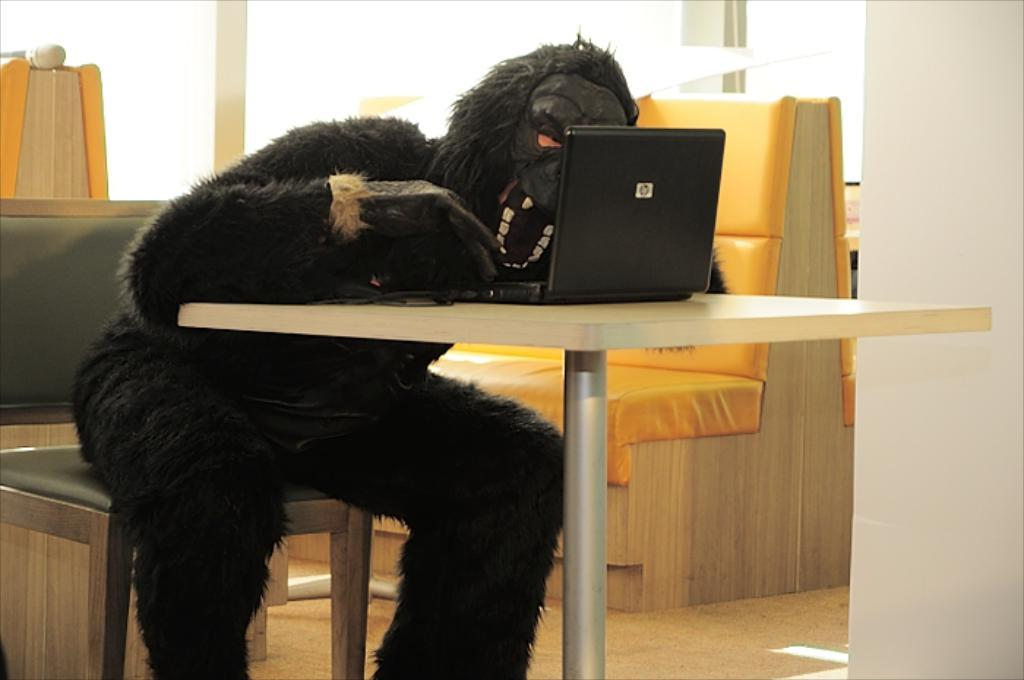What is the man in the image doing? The man is sitting on a chair in the image. Where is the man located in relation to the table? The man is beside a table in the image. What is the man wearing in the image? The man is wearing an animal costume in the image. What can be seen on the table in the image? There is a laptop on the table in the image. What type of furniture is visible in the background of the image? There are sofas in the background of the image. What type of error can be seen on the laptop screen in the image? There is no error visible on the laptop screen in the image. What is the man using to spread butter on the net in the image? There is no net or butter present in the image. 